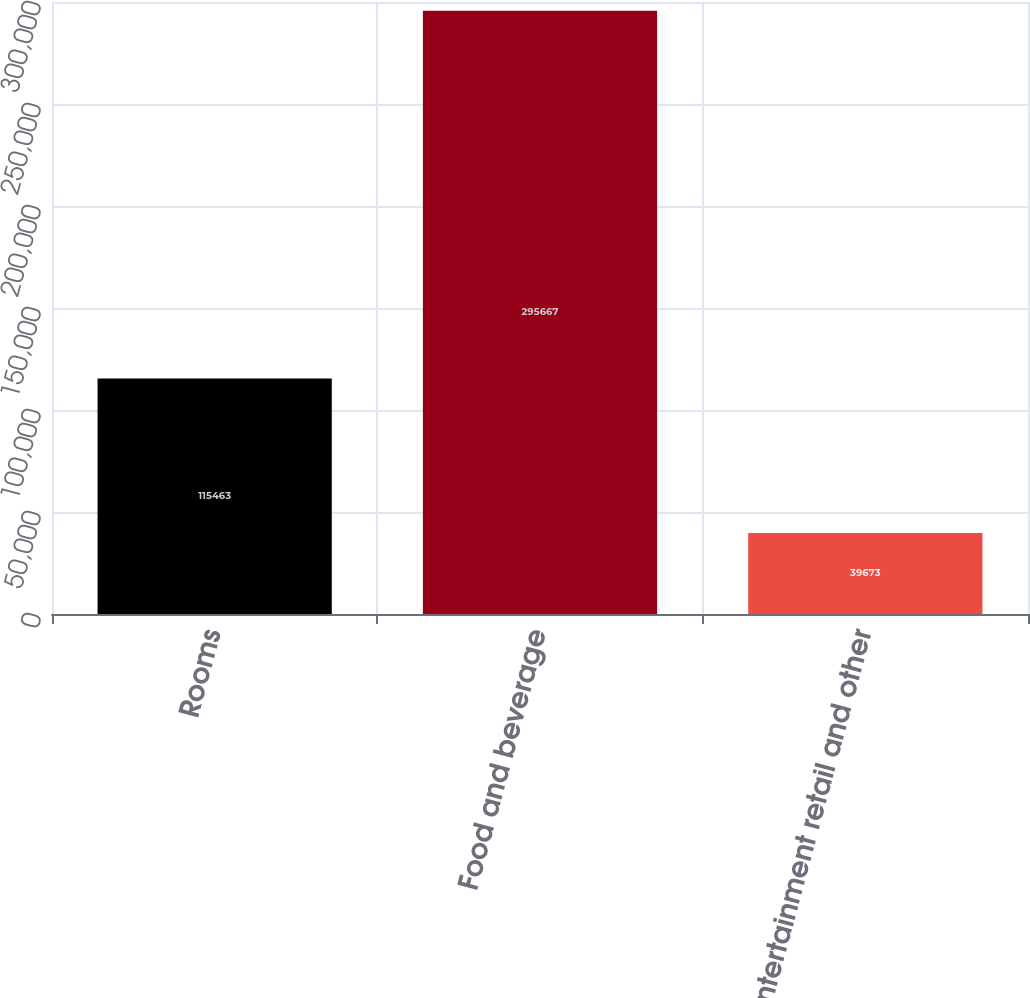<chart> <loc_0><loc_0><loc_500><loc_500><bar_chart><fcel>Rooms<fcel>Food and beverage<fcel>Entertainment retail and other<nl><fcel>115463<fcel>295667<fcel>39673<nl></chart> 